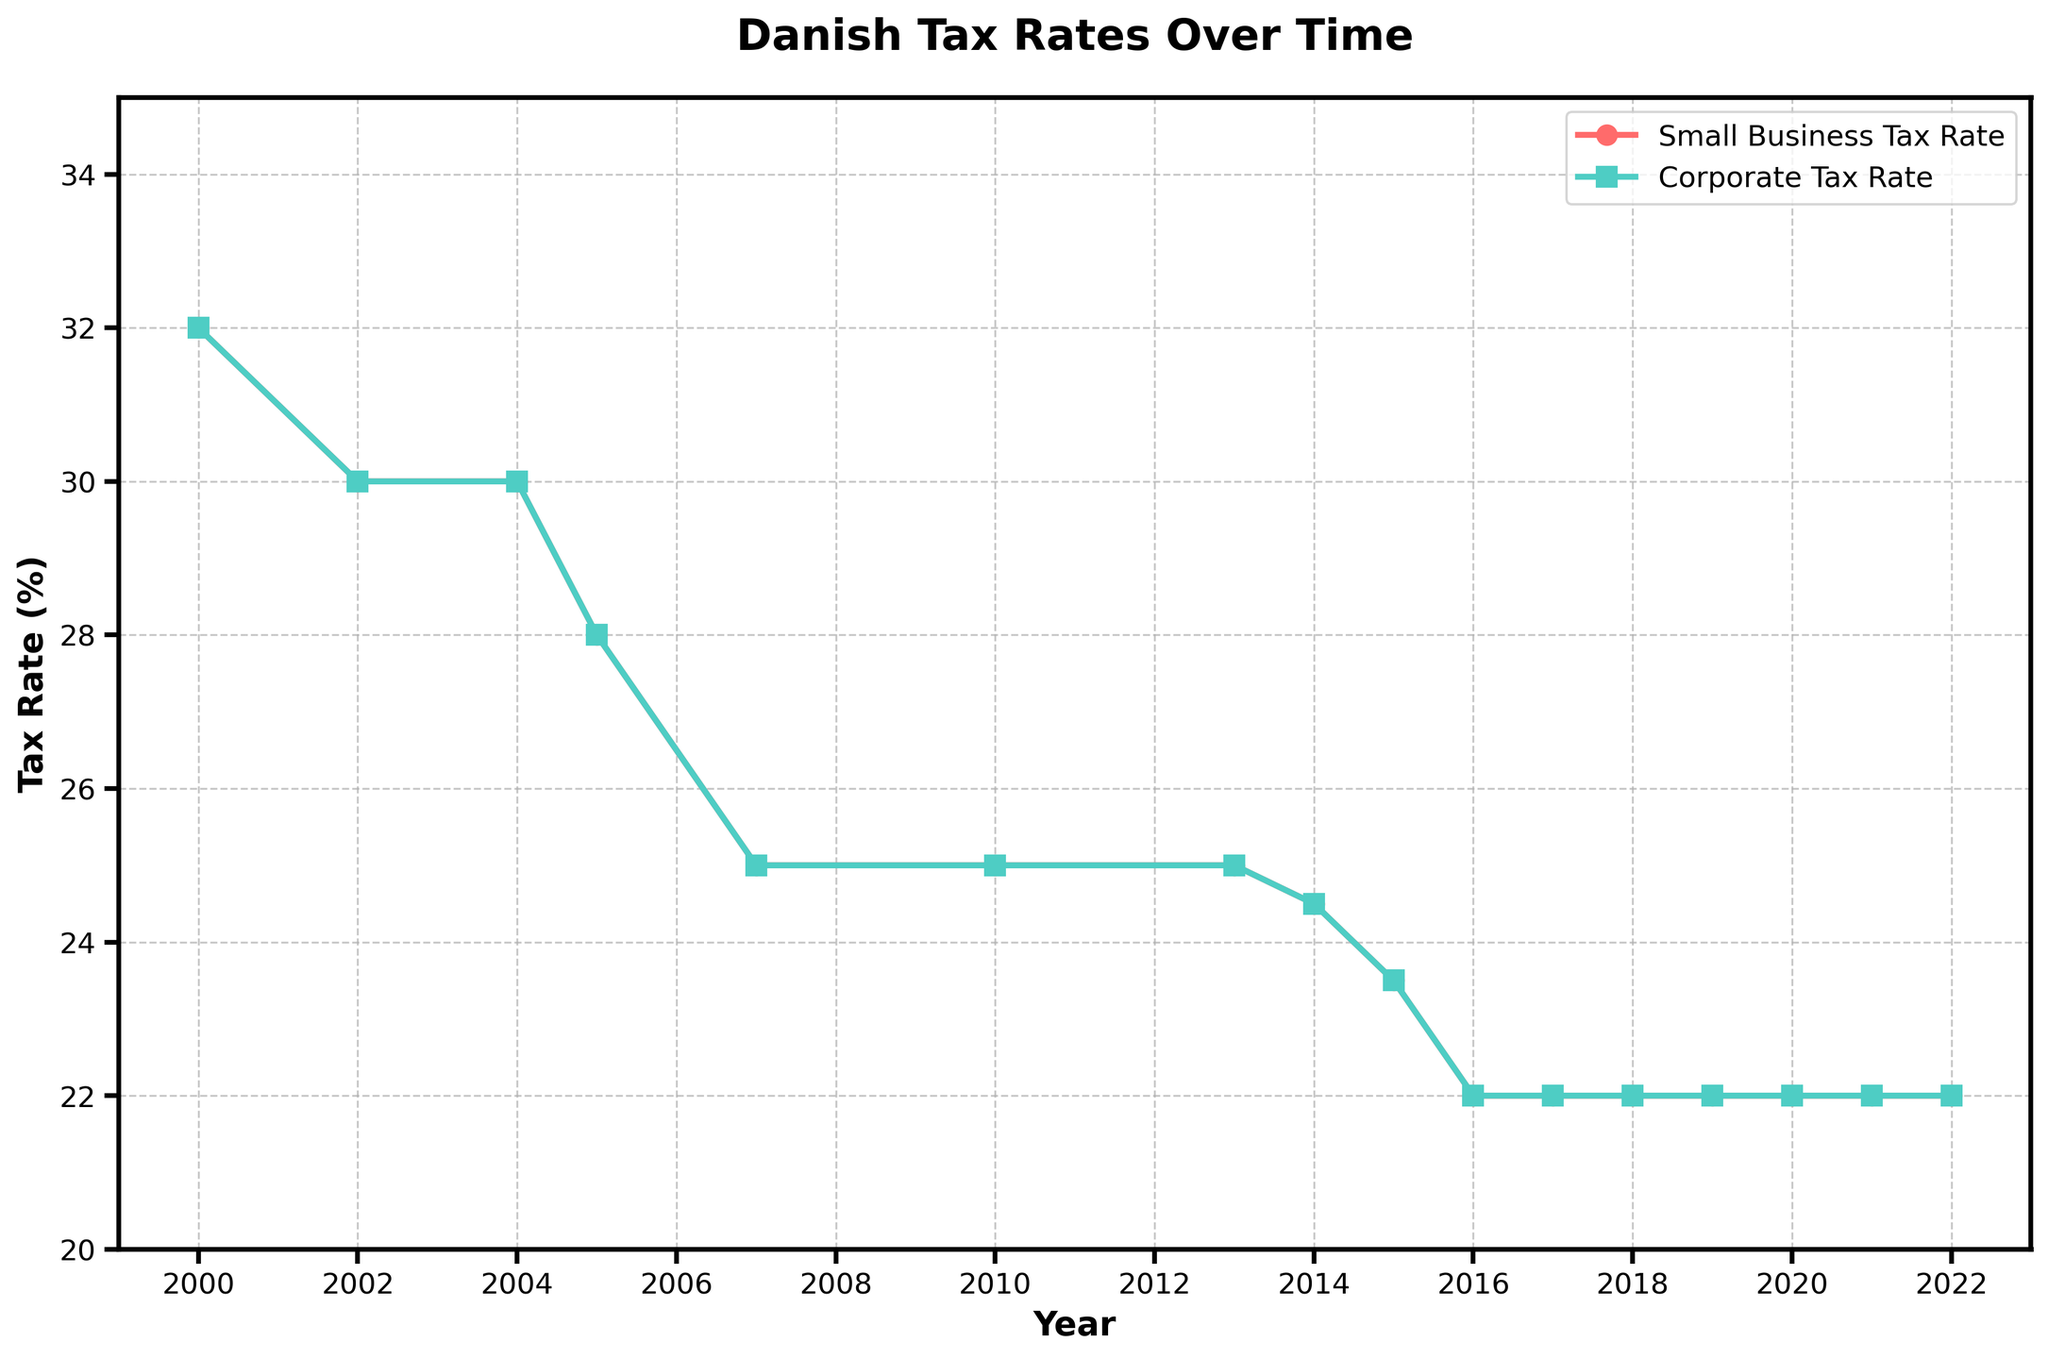What was the Small Business Tax Rate in 2000? Locate the start of the red line ('Small Business Tax Rate') at the year 2000 on the x-axis. The y-axis shows that it starts at 32%.
Answer: 32% In which year did the Corporate Tax Rate first drop below 30%? Follow the green line ('Corporate Tax Rate') starting from the year 2000 on the x-axis. The line first drops below 30% in 2005 when the rate decreased to 28%.
Answer: 2005 By how many percentage points did the Small Business Tax Rate decrease between 2013 and 2016? Identify the red line ('Small Business Tax Rate') at 2013 and 2016 on the x-axis. In 2013 the rate was 25%, and by 2016 it decreased to 22%, a reduction of 3 percentage points.
Answer: 3 Did the Corporate Tax Rate change after 2016? Observe the green line ('Corporate Tax Rate') from 2016 onwards on the x-axis. It remains flat at 22% until 2022, showing no change.
Answer: No Which tax rate has remained constant since 2017? Both lines ('Small Business Tax Rate' in red and 'Corporate Tax Rate' in green) are at 22% from 2017 to 2022. Hence, both remained constant.
Answer: Both From 2004 to 2007, by how much did the Small Business Tax Rate decrease? On the red line ('Small Business Tax Rate') from 2004 (30%) to 2007 (25%), the decrease is 5 percentage points.
Answer: 5 What is the highest value of the Corporate Tax Rate shown in the figure? Check the green line ('Corporate Tax Rate') starting from 2000. The highest value is 32% in 2000.
Answer: 32% Between which consecutive years did the largest drop in the Small Business Tax Rate occur? By examining the red line ('Small Business Tax Rate'), the largest drop (2 points) occurs between 2000 (32%) and 2002 (30%).
Answer: 2000 and 2002 What was the Small Business Tax Rate in 2010? Locate the year 2010 on the x-axis and check the red line ('Small Business Tax Rate'). The rate is 25%.
Answer: 25% How does the Corporate Tax Rate in 2002 compare to the Small Business Tax Rate in the same year? Both green ('Corporate Tax Rate') and red ('Small Business Tax Rate') lines in 2002 coincide at 30%.
Answer: Equal 